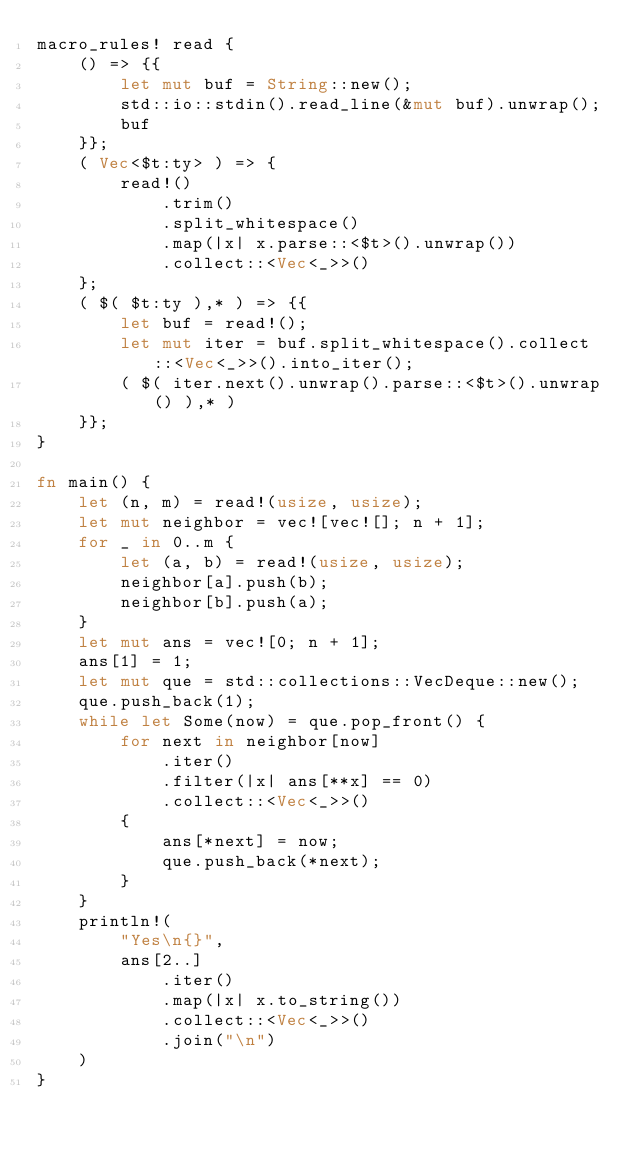<code> <loc_0><loc_0><loc_500><loc_500><_Rust_>macro_rules! read {
    () => {{
        let mut buf = String::new();
        std::io::stdin().read_line(&mut buf).unwrap();
        buf
    }};
    ( Vec<$t:ty> ) => {
        read!()
            .trim()
            .split_whitespace()
            .map(|x| x.parse::<$t>().unwrap())
            .collect::<Vec<_>>()
    };
    ( $( $t:ty ),* ) => {{
        let buf = read!();
        let mut iter = buf.split_whitespace().collect::<Vec<_>>().into_iter();
        ( $( iter.next().unwrap().parse::<$t>().unwrap() ),* )
    }};
}

fn main() {
    let (n, m) = read!(usize, usize);
    let mut neighbor = vec![vec![]; n + 1];
    for _ in 0..m {
        let (a, b) = read!(usize, usize);
        neighbor[a].push(b);
        neighbor[b].push(a);
    }
    let mut ans = vec![0; n + 1];
    ans[1] = 1;
    let mut que = std::collections::VecDeque::new();
    que.push_back(1);
    while let Some(now) = que.pop_front() {
        for next in neighbor[now]
            .iter()
            .filter(|x| ans[**x] == 0)
            .collect::<Vec<_>>()
        {
            ans[*next] = now;
            que.push_back(*next);
        }
    }
    println!(
        "Yes\n{}",
        ans[2..]
            .iter()
            .map(|x| x.to_string())
            .collect::<Vec<_>>()
            .join("\n")
    )
}
</code> 